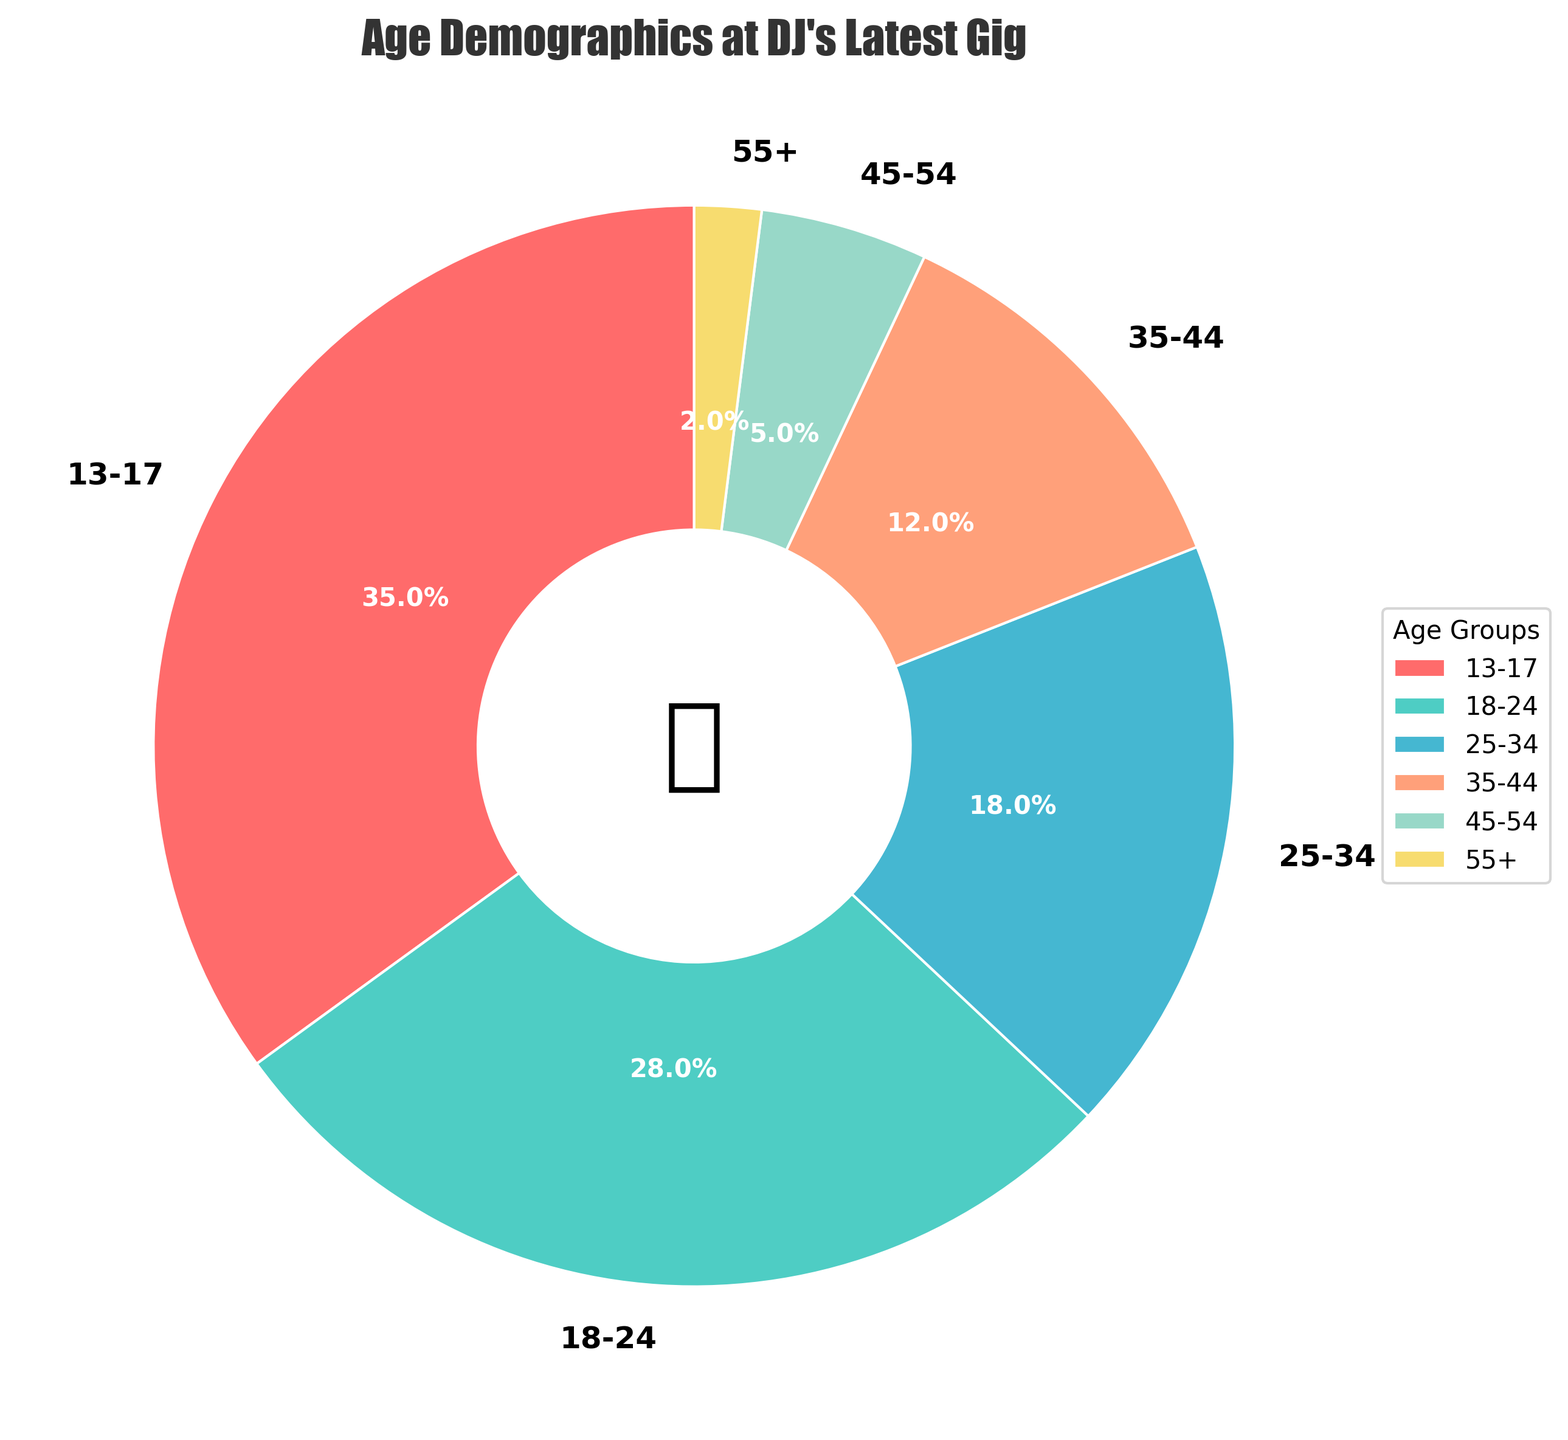What is the most represented age group at the gig? Look at the pie chart and identify the segment with the largest slice. The largest slice represents the age group 13-17 with 35%.
Answer: 13-17 Which age group has a lower percentage than the 25-34 age group? Find the percentage of the 25-34 age group, which is 18%, and compare it to other segments. The groups 35-44, 45-54, and 55+ have lower percentages (12%, 5%, 2% respectively).
Answer: 35-44, 45-54, 55+ What is the combined percentage of the age groups 35-44 and 45-54? Add the percentages of the 35-44 and 45-54 age groups: 12% + 5%.
Answer: 17% How many age groups have a percentage higher than 20%? Identify the segments with percentages above 20%: 13-17 (35%) and 18-24 (28%). There are two such groups.
Answer: 2 How does the 55+ age group percentage compare to the 45-54 age group percentage? Look at the percentages for these groups: 55+ is 2% and 45-54 is 5%. 2% is less than 5%.
Answer: Less than Which age group is represented by the green color wedge? Identify the green wedge color in the pie chart, corresponding to the 18-24 age group.
Answer: 18-24 Calculate the difference in percentage between the highest and lowest represented age groups. The highest percentage is 35% (13-17) and the lowest is 2% (55+). Subtract these: 35% - 2%.
Answer: 33% What proportion of the audience is aged above 34 years old? Sum the percentages of age groups 35-44, 45-54, and 55+: 12% + 5% + 2%.
Answer: 19% Which age groups combined make up over 50% of the audience? Identify the groups and their percentages: 13-17 (35%) and 18-24 (28%). 35% + 28% = 63%, which exceeds 50%.
Answer: 13-17 and 18-24 Given that the color red represents the 13-17 age group, what percentage does it represent? The red colored wedge represents the 13-17 age group, which has 35%.
Answer: 35% 